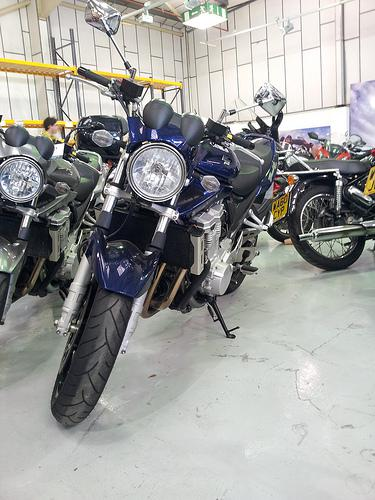Question: who is in the room?
Choices:
A. A boy and a girl.
B. No one.
C. Some men.
D. A woman.
Answer with the letter. Answer: B Question: when was the picture taken?
Choices:
A. During the day.
B. At night.
C. At dawn.
D. At Christmas.
Answer with the letter. Answer: A Question: how many bikes are the front?
Choices:
A. 3.
B. 5.
C. 8.
D. 2.
Answer with the letter. Answer: D 